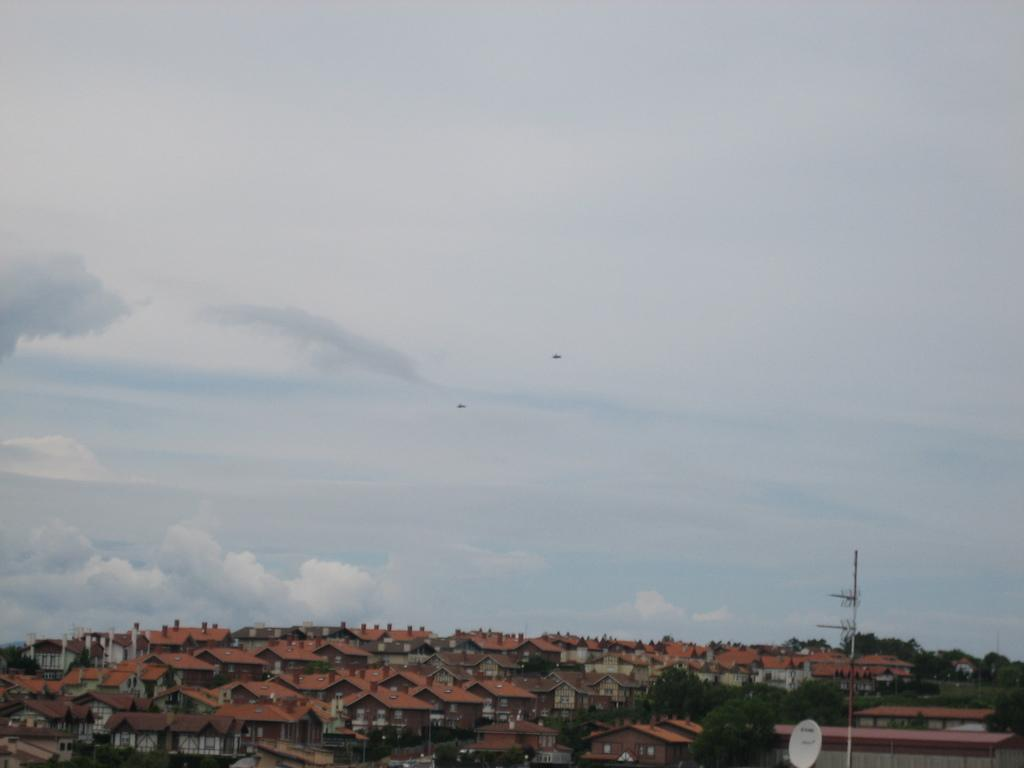What type of structures are located at the bottom of the image? There are houses at the bottom of the image. What else can be seen at the bottom of the image? There are trees and a current pole at the bottom of the image. What is the condition of the sky in the image? The sky is cloudy in the image. What can be seen in the center of the image? There are birds in the center of the image. What type of machine is being operated by the achiever in the image? There is no machine or achiever present in the image. How many birds are part of the flock in the center of the image? The image does not depict a flock of birds; it shows individual birds. 